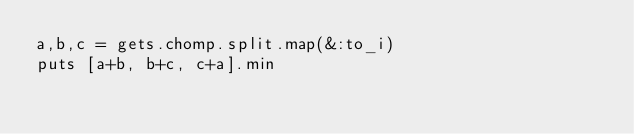<code> <loc_0><loc_0><loc_500><loc_500><_Ruby_>a,b,c = gets.chomp.split.map(&:to_i)
puts [a+b, b+c, c+a].min</code> 